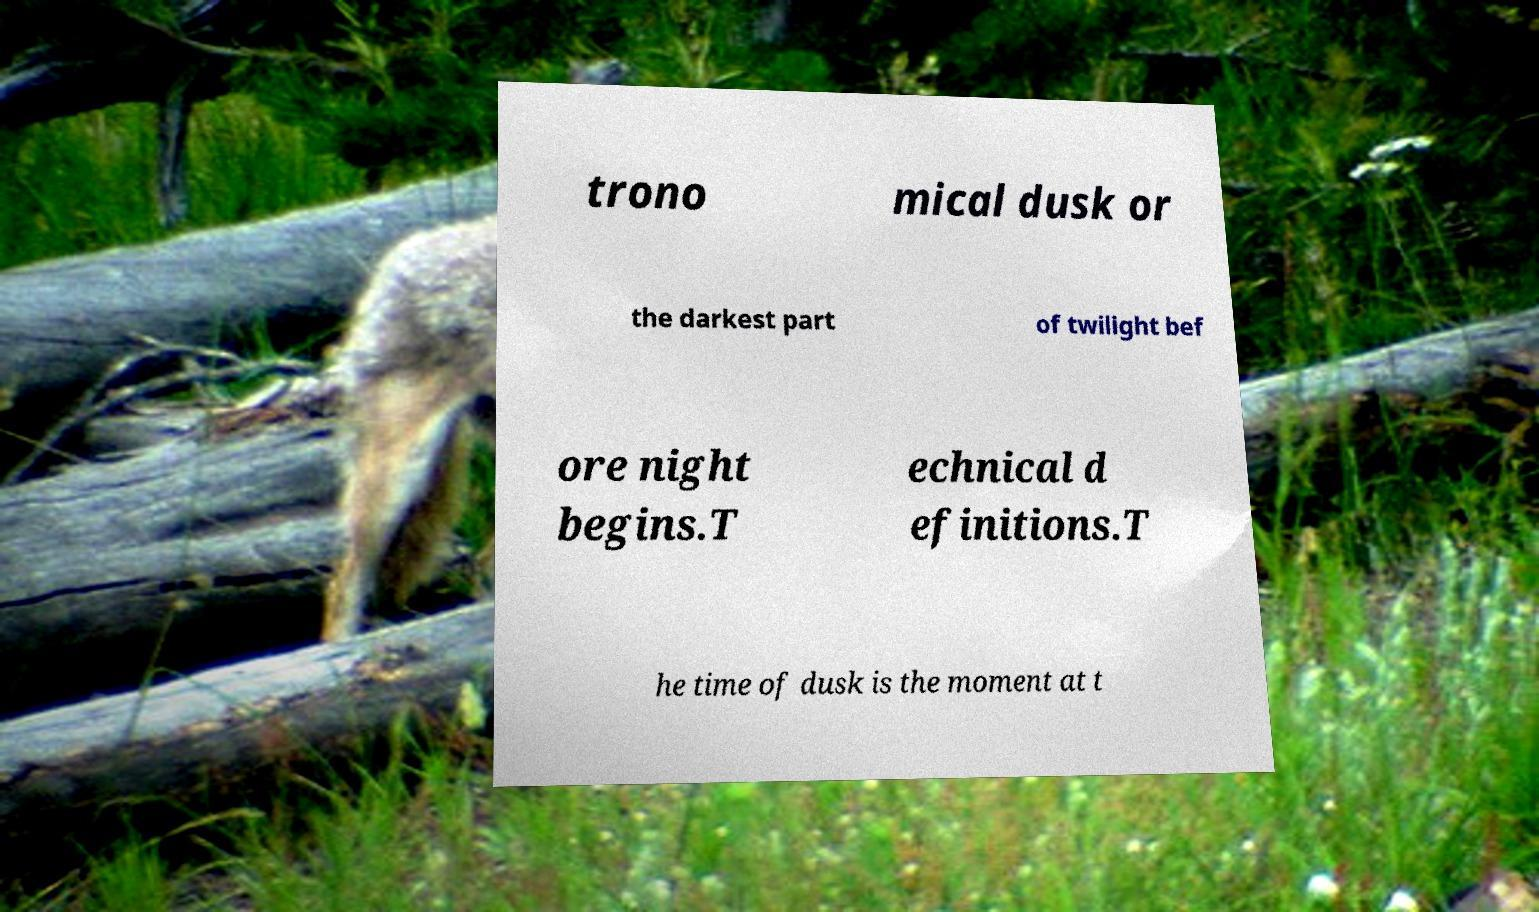Can you accurately transcribe the text from the provided image for me? trono mical dusk or the darkest part of twilight bef ore night begins.T echnical d efinitions.T he time of dusk is the moment at t 